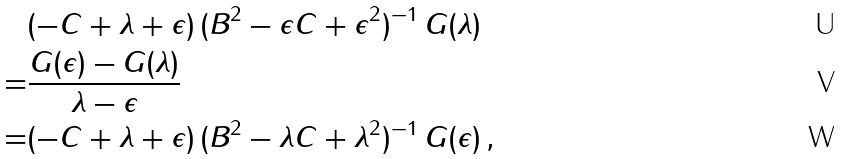Convert formula to latex. <formula><loc_0><loc_0><loc_500><loc_500>& ( - C + \lambda + \epsilon ) \, ( B ^ { 2 } - \epsilon C + \epsilon ^ { 2 } ) ^ { - 1 } \, G ( \lambda ) \\ = & \frac { G ( \epsilon ) - G ( \lambda ) } { \lambda - \epsilon } \\ = & ( - C + \lambda + \epsilon ) \, ( B ^ { 2 } - \lambda C + \lambda ^ { 2 } ) ^ { - 1 } \, G ( \epsilon ) \, ,</formula> 